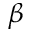Convert formula to latex. <formula><loc_0><loc_0><loc_500><loc_500>\beta</formula> 